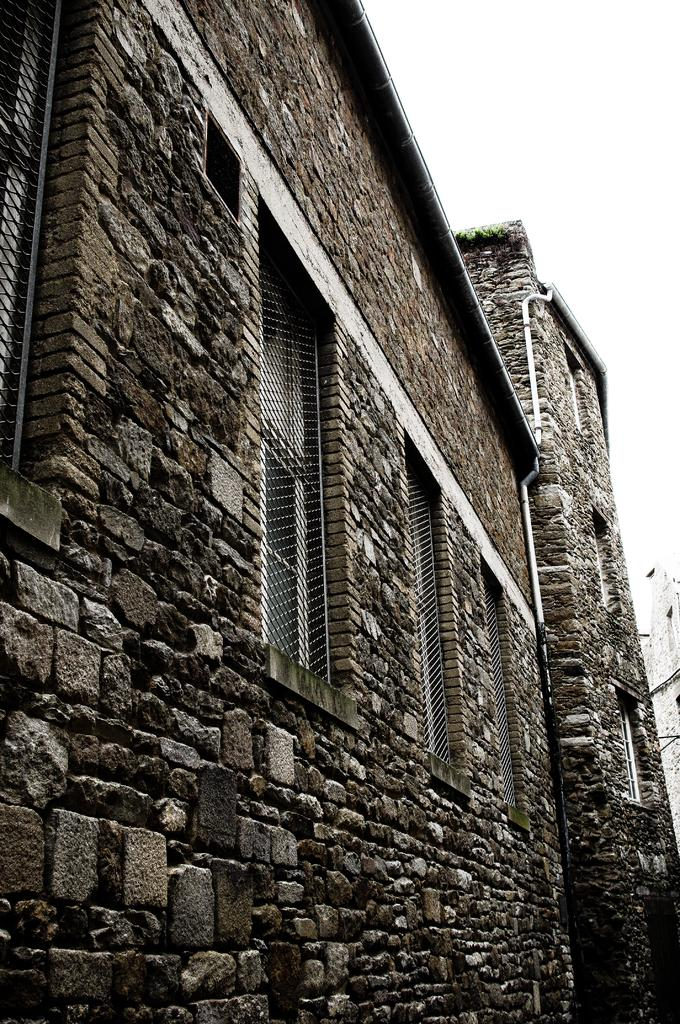What type of structure is present in the image? There is a building in the image. What are the main features of the building? The building has walls and windows. What is visible at the top of the image? The sky is visible at the top of the image. What type of amusement can be seen taking place in front of the building in the image? There is no amusement or event taking place in front of the building in the image. Is there a beggar visible in the image? There is no beggar present in the image. 